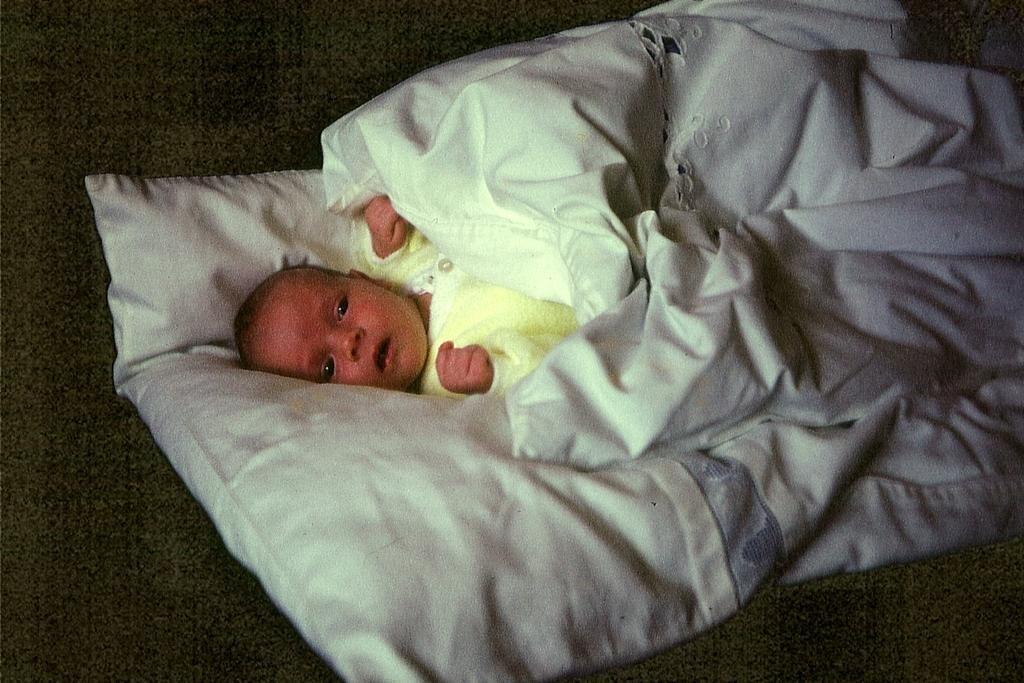What is the main subject of the image? The main subject of the image is an infant. Where is the infant located in the image? The infant is lying on a bed in the image. What is covering the infant in the image? There is a blanket over the infant in the image. What type of marble is visible in the image? There is no marble present in the image. What kind of pain is the infant experiencing in the image? The image does not provide any information about the infant's emotional or physical state, so it cannot be determined if the infant is experiencing any pain. 